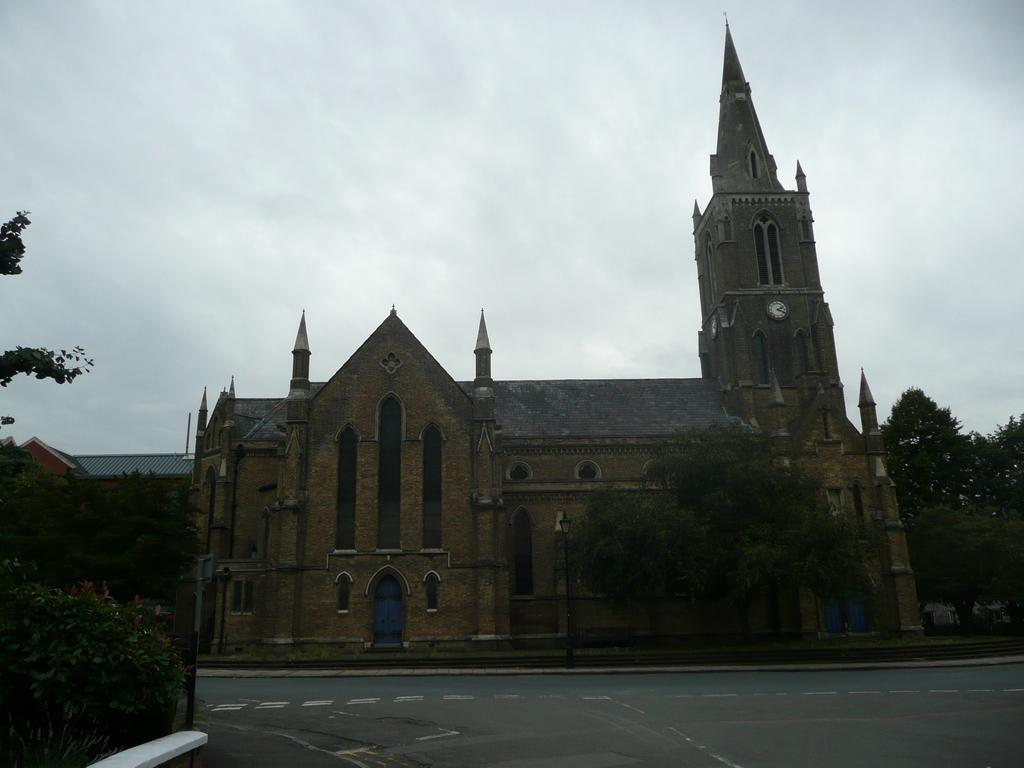What is the main structure in the center of the image? There is a building in the center of the image. What can be seen in the background of the image? There are trees in the background of the image. What is located at the bottom of the image? There is a road at the bottom of the image. What is visible at the top of the image? The sky is visible at the top of the image. What type of paper is being used for scientific experiments in the image? There is no paper or scientific experiments present in the image. What kind of noise can be heard coming from the building in the image? There is no indication of noise or any sounds in the image. 